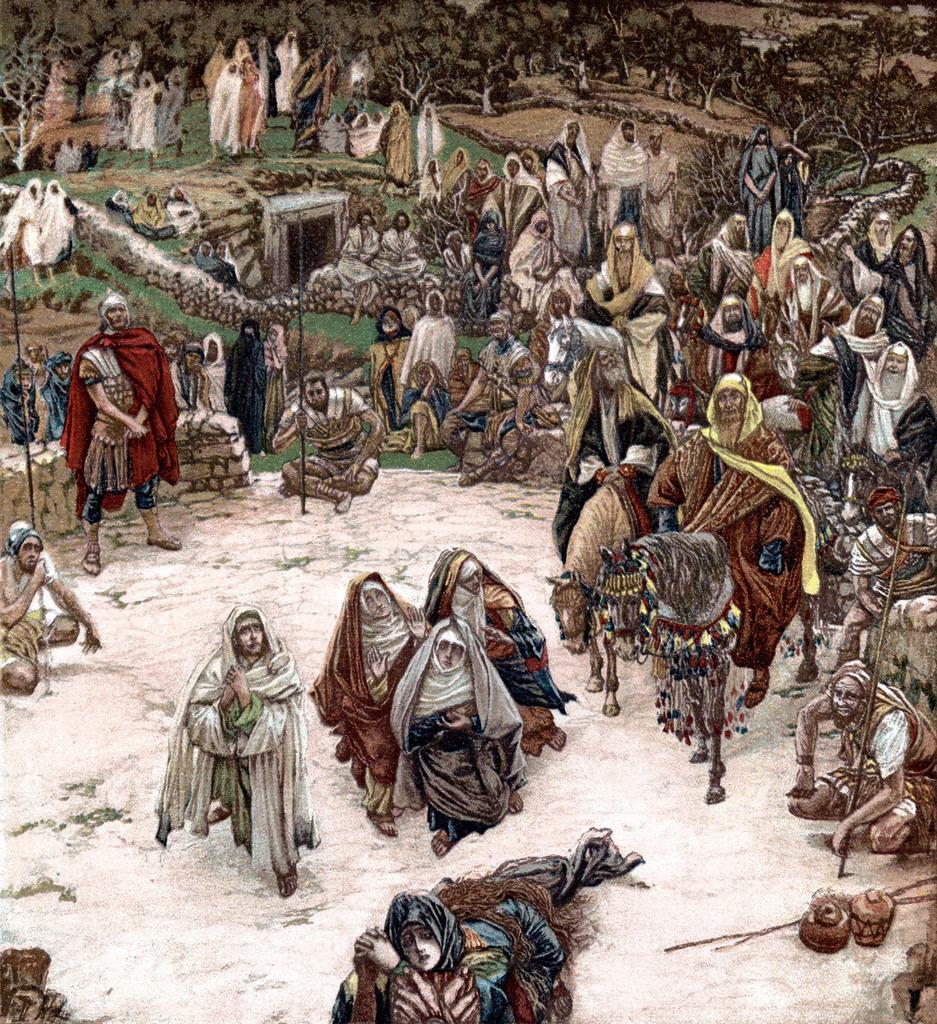How would you summarize this image in a sentence or two? Here we can see a sketch. In this sketch we can see people and horses. Background there are a number of trees.  